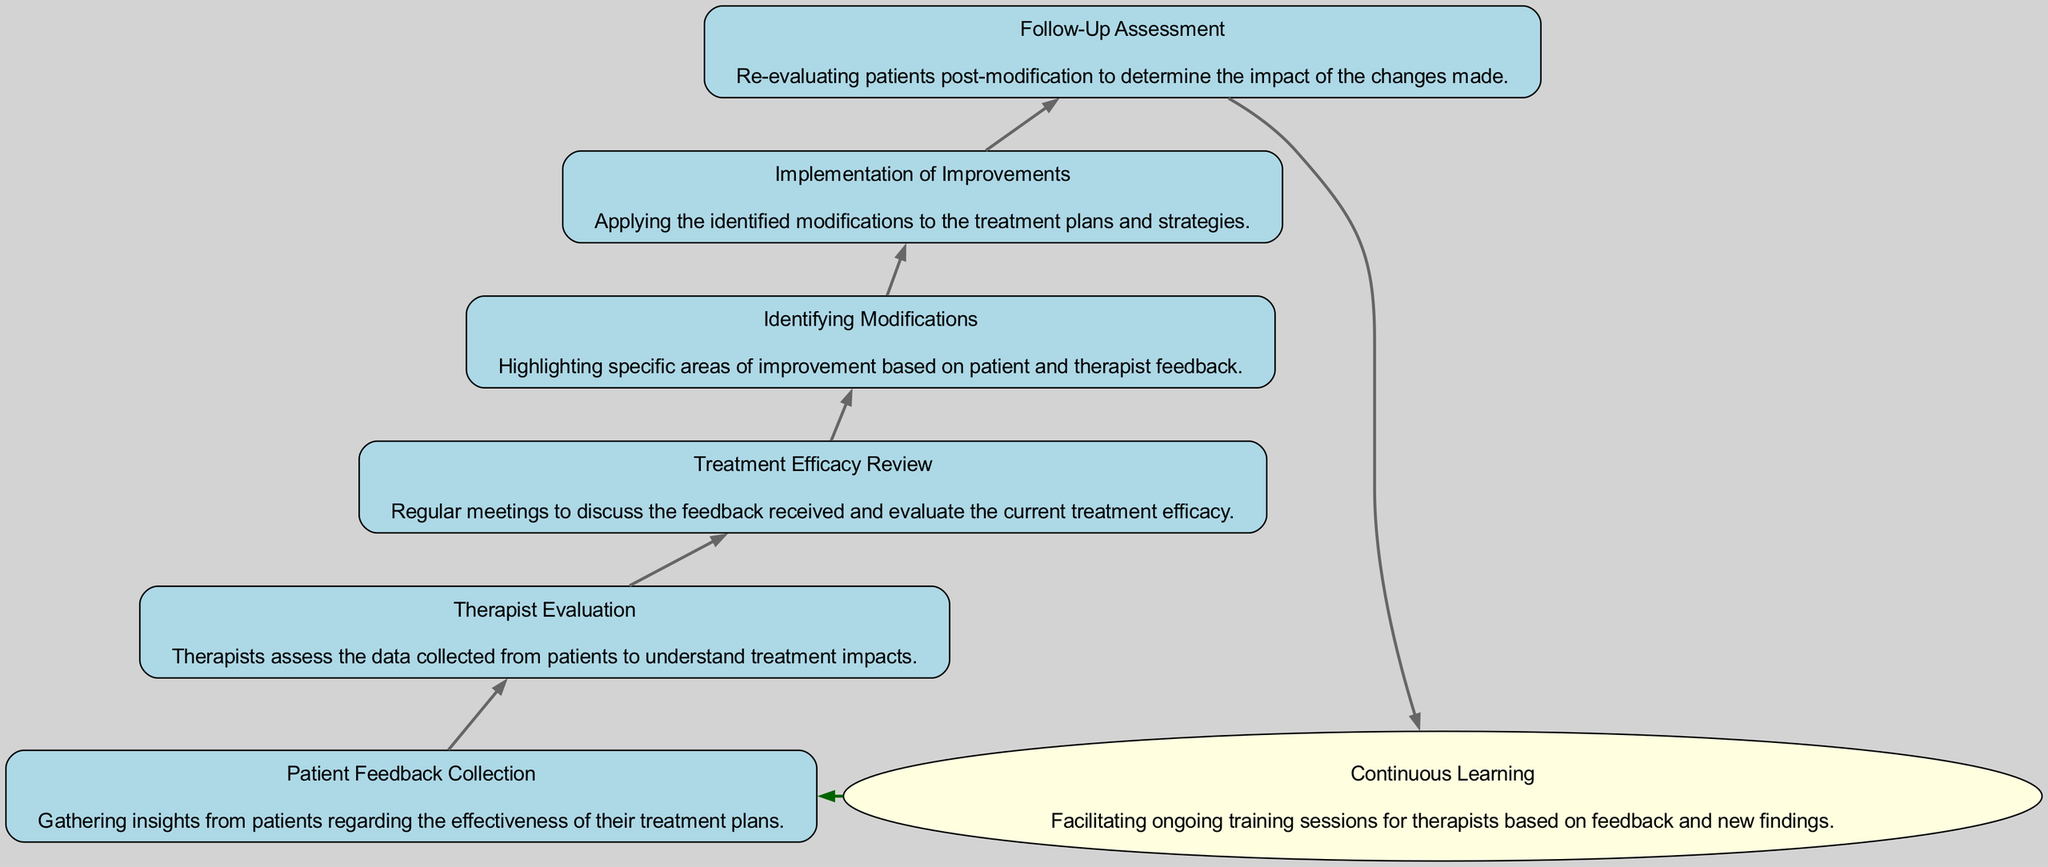What is the first step in the feedback loop? The diagram indicates that the first step is "Patient Feedback Collection," which involves gathering insights from patients regarding the effectiveness of their treatment plans.
Answer: Patient Feedback Collection How many nodes are there in the diagram? Counting the nodes presented in the diagram, there are a total of seven nodes illustrating various stages of the feedback loop.
Answer: 7 What is the last step of the sequence described in the diagram? The last step in the flow is "Follow-Up Assessment," which deals with re-evaluating patients post-modification to determine the impact of the changes made.
Answer: Follow-Up Assessment What step follows "Identifying Modifications"? After the step "Identifying Modifications," the next procedure in the sequence is "Implementation of Improvements," where identified modifications are applied to treatment plans.
Answer: Implementation of Improvements What does the step "Therapist Evaluation" assess? "Therapist Evaluation" assesses the data collected from patients, aiming to understand the impacts of the treatment based on the feedback gathered.
Answer: Data collected from patients Which step includes ongoing training sessions for therapists? The step named "Continuous Learning" facilitates ongoing training sessions for therapists based on feedback and new findings from the evaluation process.
Answer: Continuous Learning What is the purpose of "Treatment Efficacy Review"? The purpose of "Treatment Efficacy Review" is to conduct regular meetings to discuss patient feedback received and to evaluate the current treatment efficacy based on that information.
Answer: Evaluate current treatment efficacy How does "Continuous Learning" connect back to "Patient Feedback Collection"? "Continuous Learning" connects back to "Patient Feedback Collection" through a dashed line, indicating that the learning process enhances the feedback collection by incorporating new findings into subsequent treatments.
Answer: Dashed line connection 